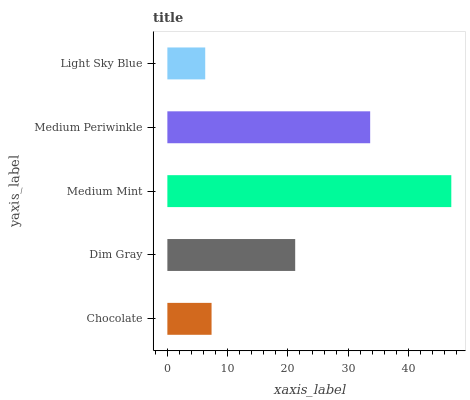Is Light Sky Blue the minimum?
Answer yes or no. Yes. Is Medium Mint the maximum?
Answer yes or no. Yes. Is Dim Gray the minimum?
Answer yes or no. No. Is Dim Gray the maximum?
Answer yes or no. No. Is Dim Gray greater than Chocolate?
Answer yes or no. Yes. Is Chocolate less than Dim Gray?
Answer yes or no. Yes. Is Chocolate greater than Dim Gray?
Answer yes or no. No. Is Dim Gray less than Chocolate?
Answer yes or no. No. Is Dim Gray the high median?
Answer yes or no. Yes. Is Dim Gray the low median?
Answer yes or no. Yes. Is Light Sky Blue the high median?
Answer yes or no. No. Is Medium Mint the low median?
Answer yes or no. No. 